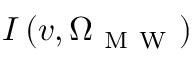<formula> <loc_0><loc_0><loc_500><loc_500>I \left ( v , \Omega _ { M W } \right )</formula> 